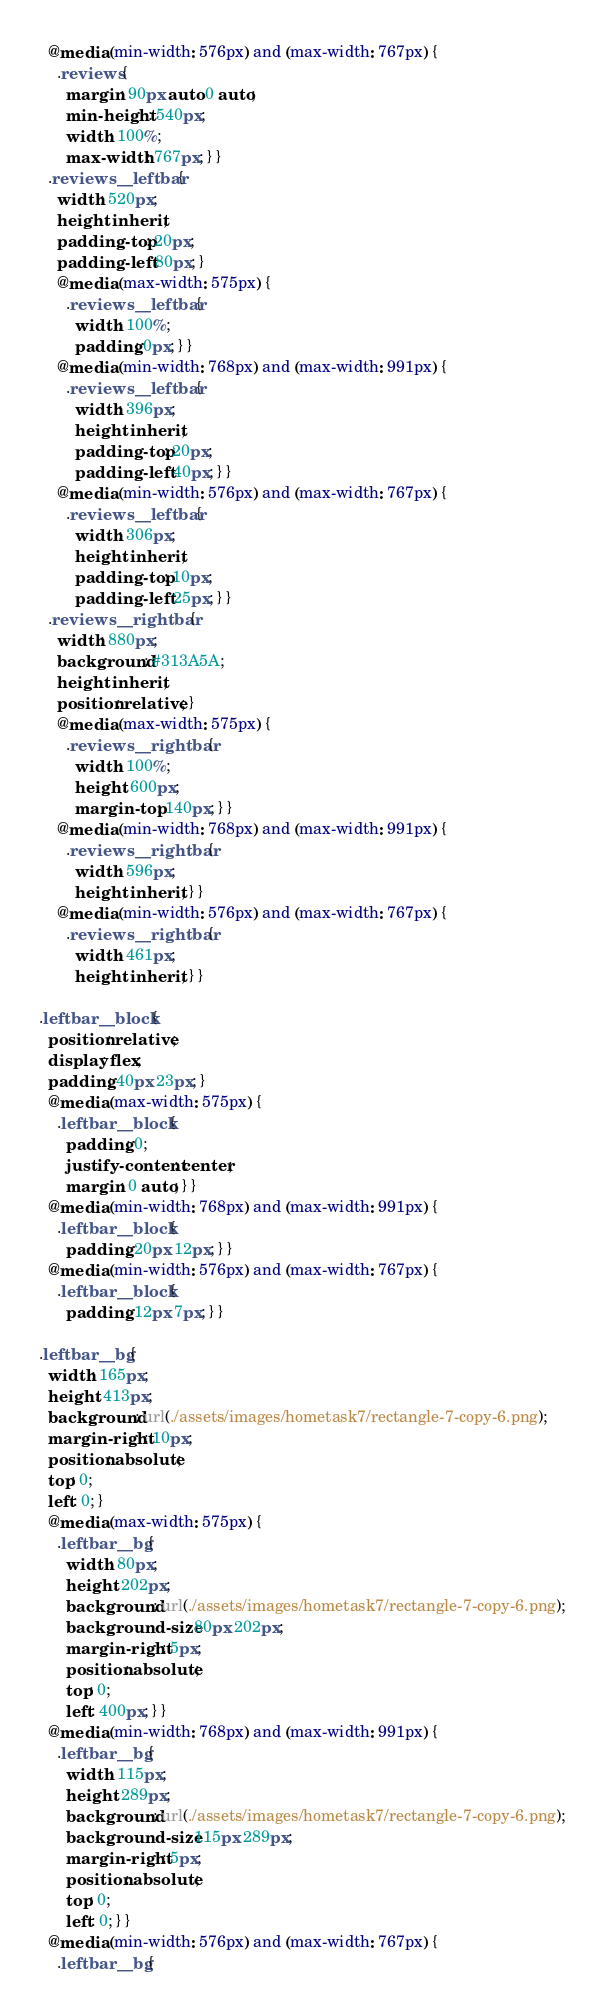<code> <loc_0><loc_0><loc_500><loc_500><_CSS_>  @media (min-width: 576px) and (max-width: 767px) {
    .reviews {
      margin: 90px auto 0 auto;
      min-height: 540px;
      width: 100%;
      max-width: 767px; } }
  .reviews__leftbar {
    width: 520px;
    height: inherit;
    padding-top: 20px;
    padding-left: 80px; }
    @media (max-width: 575px) {
      .reviews__leftbar {
        width: 100%;
        padding: 0px; } }
    @media (min-width: 768px) and (max-width: 991px) {
      .reviews__leftbar {
        width: 396px;
        height: inherit;
        padding-top: 20px;
        padding-left: 40px; } }
    @media (min-width: 576px) and (max-width: 767px) {
      .reviews__leftbar {
        width: 306px;
        height: inherit;
        padding-top: 10px;
        padding-left: 25px; } }
  .reviews__rightbar {
    width: 880px;
    background: #313A5A;
    height: inherit;
    position: relative; }
    @media (max-width: 575px) {
      .reviews__rightbar {
        width: 100%;
        height: 600px;
        margin-top: 140px; } }
    @media (min-width: 768px) and (max-width: 991px) {
      .reviews__rightbar {
        width: 596px;
        height: inherit; } }
    @media (min-width: 576px) and (max-width: 767px) {
      .reviews__rightbar {
        width: 461px;
        height: inherit; } }

.leftbar__block {
  position: relative;
  display: flex;
  padding: 40px 23px; }
  @media (max-width: 575px) {
    .leftbar__block {
      padding: 0;
      justify-content: center;
      margin: 0 auto; } }
  @media (min-width: 768px) and (max-width: 991px) {
    .leftbar__block {
      padding: 20px 12px; } }
  @media (min-width: 576px) and (max-width: 767px) {
    .leftbar__block {
      padding: 12px 7px; } }

.leftbar__bg {
  width: 165px;
  height: 413px;
  background: url(./assets/images/hometask7/rectangle-7-copy-6.png);
  margin-right: 10px;
  position: absolute;
  top: 0;
  left: 0; }
  @media (max-width: 575px) {
    .leftbar__bg {
      width: 80px;
      height: 202px;
      background: url(./assets/images/hometask7/rectangle-7-copy-6.png);
      background-size: 80px 202px;
      margin-right: 5px;
      position: absolute;
      top: 0;
      left: 400px; } }
  @media (min-width: 768px) and (max-width: 991px) {
    .leftbar__bg {
      width: 115px;
      height: 289px;
      background: url(./assets/images/hometask7/rectangle-7-copy-6.png);
      background-size: 115px 289px;
      margin-right: 5px;
      position: absolute;
      top: 0;
      left: 0; } }
  @media (min-width: 576px) and (max-width: 767px) {
    .leftbar__bg {</code> 